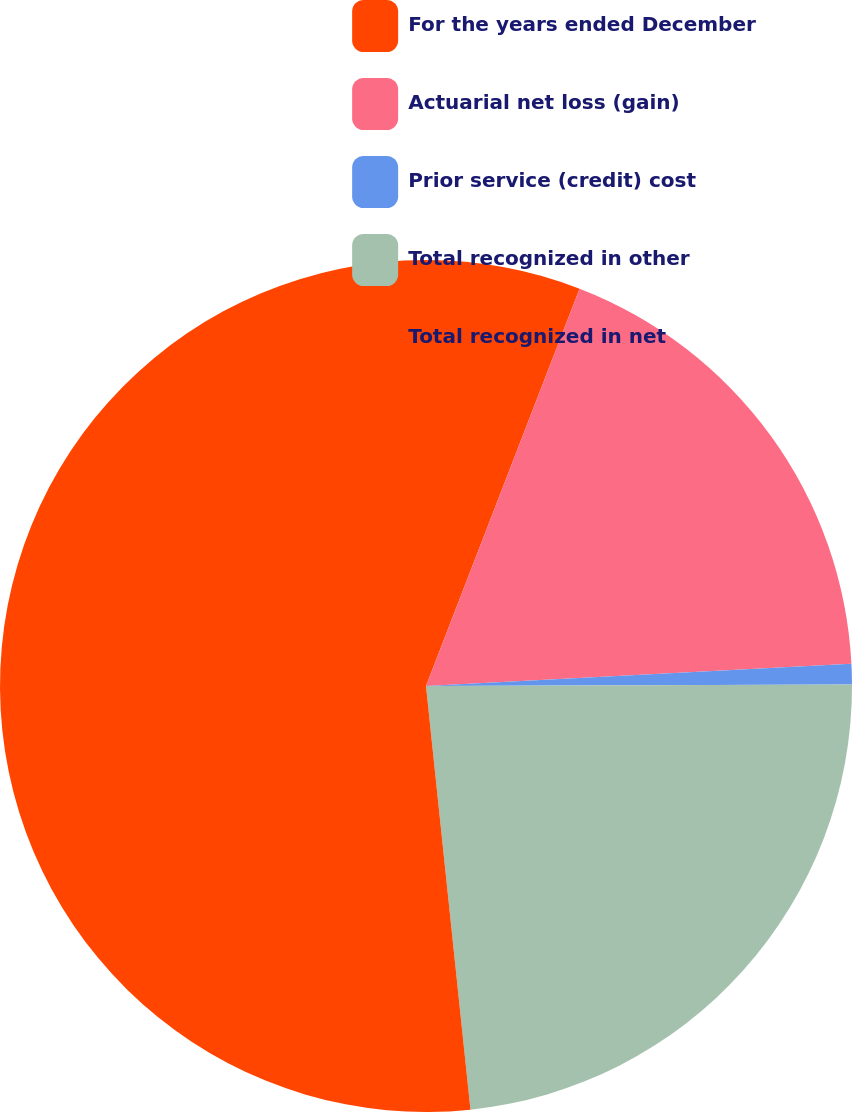Convert chart. <chart><loc_0><loc_0><loc_500><loc_500><pie_chart><fcel>For the years ended December<fcel>Actuarial net loss (gain)<fcel>Prior service (credit) cost<fcel>Total recognized in other<fcel>Total recognized in net<nl><fcel>5.87%<fcel>18.3%<fcel>0.78%<fcel>23.39%<fcel>51.67%<nl></chart> 